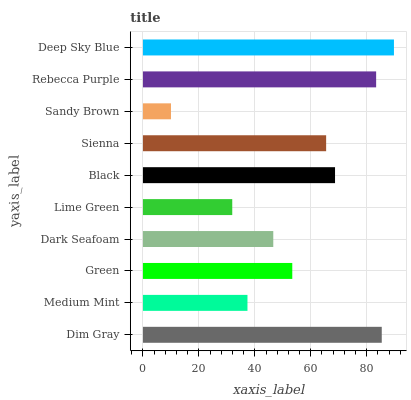Is Sandy Brown the minimum?
Answer yes or no. Yes. Is Deep Sky Blue the maximum?
Answer yes or no. Yes. Is Medium Mint the minimum?
Answer yes or no. No. Is Medium Mint the maximum?
Answer yes or no. No. Is Dim Gray greater than Medium Mint?
Answer yes or no. Yes. Is Medium Mint less than Dim Gray?
Answer yes or no. Yes. Is Medium Mint greater than Dim Gray?
Answer yes or no. No. Is Dim Gray less than Medium Mint?
Answer yes or no. No. Is Sienna the high median?
Answer yes or no. Yes. Is Green the low median?
Answer yes or no. Yes. Is Dim Gray the high median?
Answer yes or no. No. Is Sandy Brown the low median?
Answer yes or no. No. 